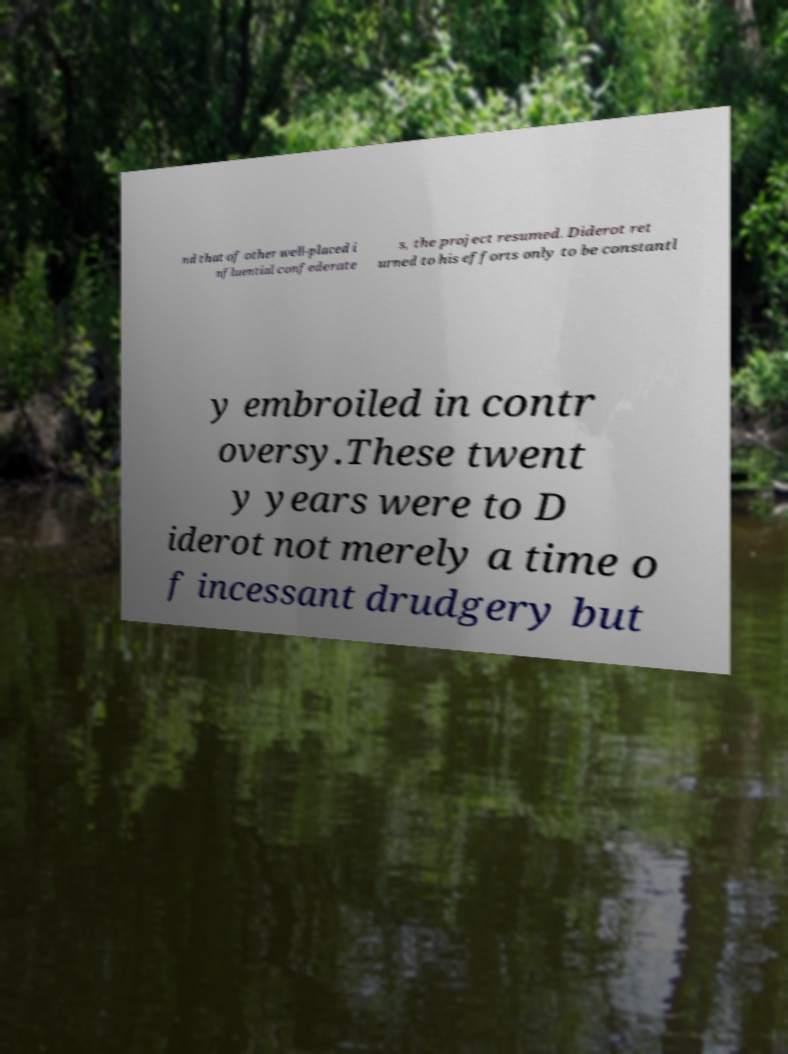There's text embedded in this image that I need extracted. Can you transcribe it verbatim? nd that of other well-placed i nfluential confederate s, the project resumed. Diderot ret urned to his efforts only to be constantl y embroiled in contr oversy.These twent y years were to D iderot not merely a time o f incessant drudgery but 